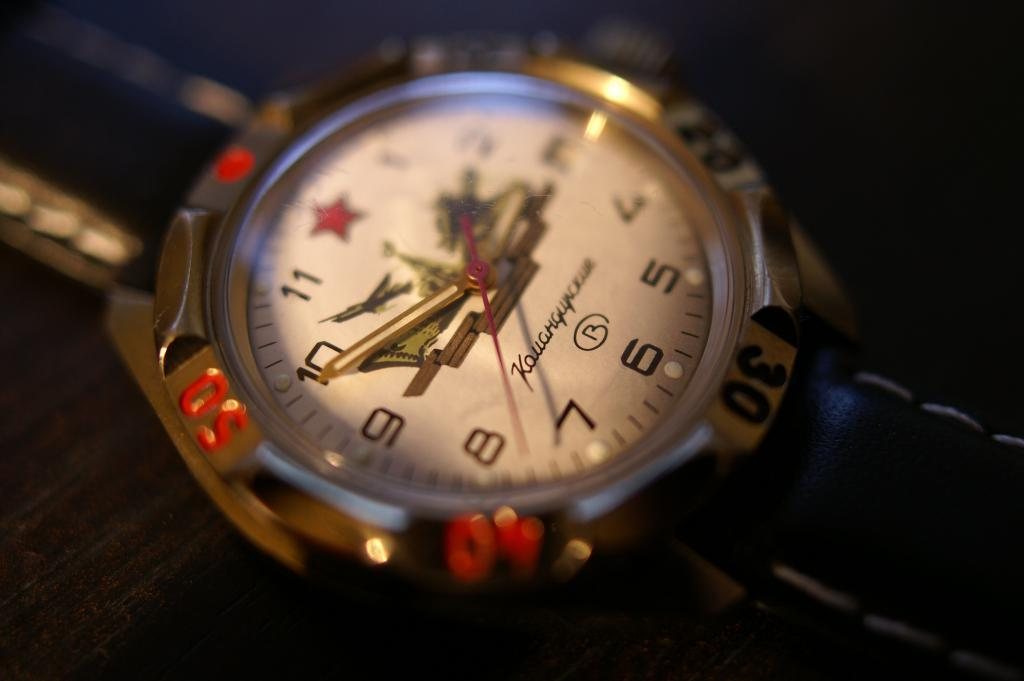<image>
Relay a brief, clear account of the picture shown. A watch that says the time is 2:49 and 39 seconds. 